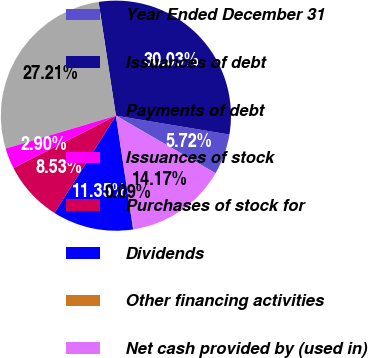Convert chart to OTSL. <chart><loc_0><loc_0><loc_500><loc_500><pie_chart><fcel>Year Ended December 31<fcel>Issuances of debt<fcel>Payments of debt<fcel>Issuances of stock<fcel>Purchases of stock for<fcel>Dividends<fcel>Other financing activities<fcel>Net cash provided by (used in)<nl><fcel>5.72%<fcel>30.03%<fcel>27.21%<fcel>2.9%<fcel>8.53%<fcel>11.35%<fcel>0.09%<fcel>14.17%<nl></chart> 